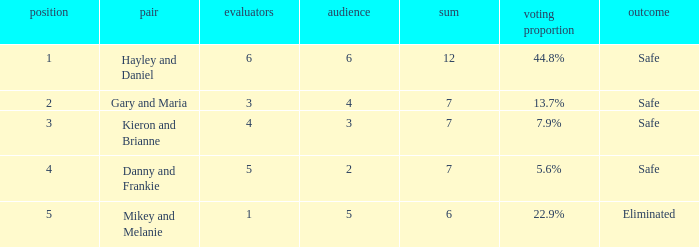What was the maximum rank for the vote percentage of 5.6% 4.0. 